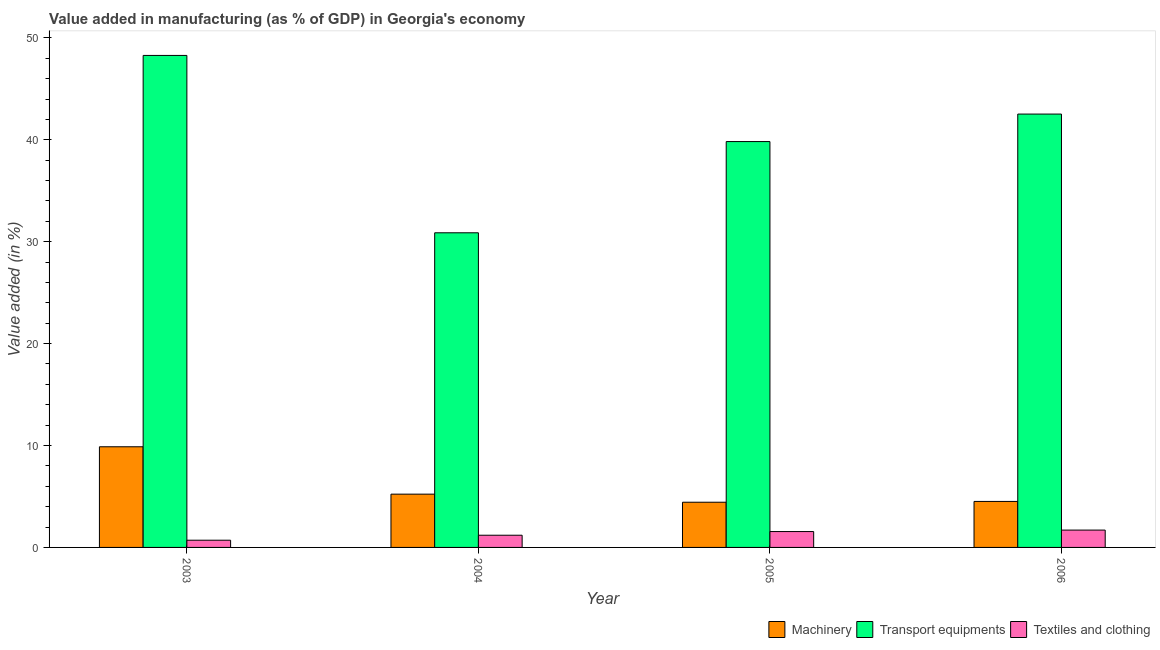How many different coloured bars are there?
Keep it short and to the point. 3. Are the number of bars on each tick of the X-axis equal?
Your answer should be very brief. Yes. In how many cases, is the number of bars for a given year not equal to the number of legend labels?
Your answer should be compact. 0. What is the value added in manufacturing machinery in 2005?
Your answer should be compact. 4.44. Across all years, what is the maximum value added in manufacturing transport equipments?
Give a very brief answer. 48.28. Across all years, what is the minimum value added in manufacturing textile and clothing?
Your answer should be very brief. 0.71. In which year was the value added in manufacturing textile and clothing minimum?
Provide a short and direct response. 2003. What is the total value added in manufacturing machinery in the graph?
Provide a succinct answer. 24.05. What is the difference between the value added in manufacturing machinery in 2005 and that in 2006?
Make the answer very short. -0.08. What is the difference between the value added in manufacturing transport equipments in 2005 and the value added in manufacturing machinery in 2004?
Keep it short and to the point. 8.95. What is the average value added in manufacturing transport equipments per year?
Your answer should be very brief. 40.37. In how many years, is the value added in manufacturing transport equipments greater than 4 %?
Provide a short and direct response. 4. What is the ratio of the value added in manufacturing machinery in 2004 to that in 2006?
Give a very brief answer. 1.16. What is the difference between the highest and the second highest value added in manufacturing transport equipments?
Make the answer very short. 5.75. What is the difference between the highest and the lowest value added in manufacturing transport equipments?
Your answer should be compact. 17.4. What does the 1st bar from the left in 2006 represents?
Provide a short and direct response. Machinery. What does the 2nd bar from the right in 2003 represents?
Keep it short and to the point. Transport equipments. Is it the case that in every year, the sum of the value added in manufacturing machinery and value added in manufacturing transport equipments is greater than the value added in manufacturing textile and clothing?
Offer a very short reply. Yes. How many bars are there?
Your response must be concise. 12. How many years are there in the graph?
Your answer should be compact. 4. What is the difference between two consecutive major ticks on the Y-axis?
Keep it short and to the point. 10. Does the graph contain any zero values?
Your answer should be very brief. No. How are the legend labels stacked?
Provide a succinct answer. Horizontal. What is the title of the graph?
Your answer should be very brief. Value added in manufacturing (as % of GDP) in Georgia's economy. What is the label or title of the Y-axis?
Provide a short and direct response. Value added (in %). What is the Value added (in %) in Machinery in 2003?
Give a very brief answer. 9.88. What is the Value added (in %) of Transport equipments in 2003?
Provide a short and direct response. 48.28. What is the Value added (in %) of Textiles and clothing in 2003?
Your answer should be compact. 0.71. What is the Value added (in %) of Machinery in 2004?
Give a very brief answer. 5.23. What is the Value added (in %) in Transport equipments in 2004?
Your response must be concise. 30.87. What is the Value added (in %) of Textiles and clothing in 2004?
Keep it short and to the point. 1.2. What is the Value added (in %) in Machinery in 2005?
Offer a terse response. 4.44. What is the Value added (in %) of Transport equipments in 2005?
Your answer should be compact. 39.82. What is the Value added (in %) of Textiles and clothing in 2005?
Offer a terse response. 1.56. What is the Value added (in %) in Machinery in 2006?
Your answer should be very brief. 4.51. What is the Value added (in %) of Transport equipments in 2006?
Provide a succinct answer. 42.52. What is the Value added (in %) of Textiles and clothing in 2006?
Your answer should be very brief. 1.7. Across all years, what is the maximum Value added (in %) in Machinery?
Offer a terse response. 9.88. Across all years, what is the maximum Value added (in %) of Transport equipments?
Ensure brevity in your answer.  48.28. Across all years, what is the maximum Value added (in %) in Textiles and clothing?
Your answer should be compact. 1.7. Across all years, what is the minimum Value added (in %) in Machinery?
Keep it short and to the point. 4.44. Across all years, what is the minimum Value added (in %) in Transport equipments?
Keep it short and to the point. 30.87. Across all years, what is the minimum Value added (in %) in Textiles and clothing?
Your answer should be compact. 0.71. What is the total Value added (in %) in Machinery in the graph?
Your answer should be very brief. 24.05. What is the total Value added (in %) of Transport equipments in the graph?
Provide a short and direct response. 161.5. What is the total Value added (in %) of Textiles and clothing in the graph?
Make the answer very short. 5.16. What is the difference between the Value added (in %) of Machinery in 2003 and that in 2004?
Your answer should be compact. 4.65. What is the difference between the Value added (in %) in Transport equipments in 2003 and that in 2004?
Your answer should be very brief. 17.4. What is the difference between the Value added (in %) of Textiles and clothing in 2003 and that in 2004?
Give a very brief answer. -0.49. What is the difference between the Value added (in %) of Machinery in 2003 and that in 2005?
Provide a short and direct response. 5.44. What is the difference between the Value added (in %) in Transport equipments in 2003 and that in 2005?
Your answer should be very brief. 8.45. What is the difference between the Value added (in %) of Textiles and clothing in 2003 and that in 2005?
Your answer should be compact. -0.85. What is the difference between the Value added (in %) of Machinery in 2003 and that in 2006?
Your answer should be compact. 5.36. What is the difference between the Value added (in %) in Transport equipments in 2003 and that in 2006?
Give a very brief answer. 5.75. What is the difference between the Value added (in %) of Textiles and clothing in 2003 and that in 2006?
Your response must be concise. -0.99. What is the difference between the Value added (in %) of Machinery in 2004 and that in 2005?
Keep it short and to the point. 0.79. What is the difference between the Value added (in %) of Transport equipments in 2004 and that in 2005?
Provide a succinct answer. -8.95. What is the difference between the Value added (in %) in Textiles and clothing in 2004 and that in 2005?
Your response must be concise. -0.36. What is the difference between the Value added (in %) in Machinery in 2004 and that in 2006?
Provide a succinct answer. 0.71. What is the difference between the Value added (in %) in Transport equipments in 2004 and that in 2006?
Offer a very short reply. -11.65. What is the difference between the Value added (in %) in Textiles and clothing in 2004 and that in 2006?
Provide a succinct answer. -0.51. What is the difference between the Value added (in %) of Machinery in 2005 and that in 2006?
Provide a short and direct response. -0.08. What is the difference between the Value added (in %) in Transport equipments in 2005 and that in 2006?
Offer a terse response. -2.7. What is the difference between the Value added (in %) of Textiles and clothing in 2005 and that in 2006?
Your answer should be compact. -0.15. What is the difference between the Value added (in %) of Machinery in 2003 and the Value added (in %) of Transport equipments in 2004?
Your answer should be compact. -21. What is the difference between the Value added (in %) in Machinery in 2003 and the Value added (in %) in Textiles and clothing in 2004?
Your answer should be compact. 8.68. What is the difference between the Value added (in %) of Transport equipments in 2003 and the Value added (in %) of Textiles and clothing in 2004?
Your answer should be very brief. 47.08. What is the difference between the Value added (in %) of Machinery in 2003 and the Value added (in %) of Transport equipments in 2005?
Offer a terse response. -29.95. What is the difference between the Value added (in %) of Machinery in 2003 and the Value added (in %) of Textiles and clothing in 2005?
Provide a succinct answer. 8.32. What is the difference between the Value added (in %) in Transport equipments in 2003 and the Value added (in %) in Textiles and clothing in 2005?
Ensure brevity in your answer.  46.72. What is the difference between the Value added (in %) of Machinery in 2003 and the Value added (in %) of Transport equipments in 2006?
Ensure brevity in your answer.  -32.65. What is the difference between the Value added (in %) of Machinery in 2003 and the Value added (in %) of Textiles and clothing in 2006?
Provide a short and direct response. 8.17. What is the difference between the Value added (in %) in Transport equipments in 2003 and the Value added (in %) in Textiles and clothing in 2006?
Provide a succinct answer. 46.57. What is the difference between the Value added (in %) in Machinery in 2004 and the Value added (in %) in Transport equipments in 2005?
Provide a short and direct response. -34.6. What is the difference between the Value added (in %) of Machinery in 2004 and the Value added (in %) of Textiles and clothing in 2005?
Offer a very short reply. 3.67. What is the difference between the Value added (in %) of Transport equipments in 2004 and the Value added (in %) of Textiles and clothing in 2005?
Your answer should be compact. 29.32. What is the difference between the Value added (in %) in Machinery in 2004 and the Value added (in %) in Transport equipments in 2006?
Ensure brevity in your answer.  -37.29. What is the difference between the Value added (in %) in Machinery in 2004 and the Value added (in %) in Textiles and clothing in 2006?
Offer a very short reply. 3.53. What is the difference between the Value added (in %) in Transport equipments in 2004 and the Value added (in %) in Textiles and clothing in 2006?
Give a very brief answer. 29.17. What is the difference between the Value added (in %) in Machinery in 2005 and the Value added (in %) in Transport equipments in 2006?
Offer a terse response. -38.09. What is the difference between the Value added (in %) of Machinery in 2005 and the Value added (in %) of Textiles and clothing in 2006?
Make the answer very short. 2.73. What is the difference between the Value added (in %) of Transport equipments in 2005 and the Value added (in %) of Textiles and clothing in 2006?
Ensure brevity in your answer.  38.12. What is the average Value added (in %) of Machinery per year?
Your answer should be compact. 6.01. What is the average Value added (in %) of Transport equipments per year?
Keep it short and to the point. 40.37. What is the average Value added (in %) in Textiles and clothing per year?
Give a very brief answer. 1.29. In the year 2003, what is the difference between the Value added (in %) of Machinery and Value added (in %) of Transport equipments?
Your response must be concise. -38.4. In the year 2003, what is the difference between the Value added (in %) in Machinery and Value added (in %) in Textiles and clothing?
Your answer should be compact. 9.17. In the year 2003, what is the difference between the Value added (in %) in Transport equipments and Value added (in %) in Textiles and clothing?
Your response must be concise. 47.57. In the year 2004, what is the difference between the Value added (in %) of Machinery and Value added (in %) of Transport equipments?
Provide a short and direct response. -25.65. In the year 2004, what is the difference between the Value added (in %) of Machinery and Value added (in %) of Textiles and clothing?
Offer a very short reply. 4.03. In the year 2004, what is the difference between the Value added (in %) of Transport equipments and Value added (in %) of Textiles and clothing?
Make the answer very short. 29.68. In the year 2005, what is the difference between the Value added (in %) of Machinery and Value added (in %) of Transport equipments?
Your answer should be very brief. -35.39. In the year 2005, what is the difference between the Value added (in %) in Machinery and Value added (in %) in Textiles and clothing?
Your response must be concise. 2.88. In the year 2005, what is the difference between the Value added (in %) of Transport equipments and Value added (in %) of Textiles and clothing?
Your answer should be compact. 38.27. In the year 2006, what is the difference between the Value added (in %) of Machinery and Value added (in %) of Transport equipments?
Your answer should be compact. -38.01. In the year 2006, what is the difference between the Value added (in %) in Machinery and Value added (in %) in Textiles and clothing?
Provide a short and direct response. 2.81. In the year 2006, what is the difference between the Value added (in %) in Transport equipments and Value added (in %) in Textiles and clothing?
Your response must be concise. 40.82. What is the ratio of the Value added (in %) in Machinery in 2003 to that in 2004?
Make the answer very short. 1.89. What is the ratio of the Value added (in %) of Transport equipments in 2003 to that in 2004?
Offer a terse response. 1.56. What is the ratio of the Value added (in %) of Textiles and clothing in 2003 to that in 2004?
Your answer should be compact. 0.59. What is the ratio of the Value added (in %) of Machinery in 2003 to that in 2005?
Provide a short and direct response. 2.23. What is the ratio of the Value added (in %) in Transport equipments in 2003 to that in 2005?
Your answer should be very brief. 1.21. What is the ratio of the Value added (in %) of Textiles and clothing in 2003 to that in 2005?
Ensure brevity in your answer.  0.45. What is the ratio of the Value added (in %) of Machinery in 2003 to that in 2006?
Ensure brevity in your answer.  2.19. What is the ratio of the Value added (in %) in Transport equipments in 2003 to that in 2006?
Offer a very short reply. 1.14. What is the ratio of the Value added (in %) in Textiles and clothing in 2003 to that in 2006?
Your response must be concise. 0.42. What is the ratio of the Value added (in %) of Machinery in 2004 to that in 2005?
Your answer should be compact. 1.18. What is the ratio of the Value added (in %) of Transport equipments in 2004 to that in 2005?
Ensure brevity in your answer.  0.78. What is the ratio of the Value added (in %) of Textiles and clothing in 2004 to that in 2005?
Provide a succinct answer. 0.77. What is the ratio of the Value added (in %) in Machinery in 2004 to that in 2006?
Provide a short and direct response. 1.16. What is the ratio of the Value added (in %) of Transport equipments in 2004 to that in 2006?
Make the answer very short. 0.73. What is the ratio of the Value added (in %) in Textiles and clothing in 2004 to that in 2006?
Your response must be concise. 0.7. What is the ratio of the Value added (in %) in Machinery in 2005 to that in 2006?
Offer a very short reply. 0.98. What is the ratio of the Value added (in %) in Transport equipments in 2005 to that in 2006?
Provide a short and direct response. 0.94. What is the ratio of the Value added (in %) in Textiles and clothing in 2005 to that in 2006?
Provide a succinct answer. 0.91. What is the difference between the highest and the second highest Value added (in %) of Machinery?
Your answer should be compact. 4.65. What is the difference between the highest and the second highest Value added (in %) in Transport equipments?
Make the answer very short. 5.75. What is the difference between the highest and the second highest Value added (in %) in Textiles and clothing?
Make the answer very short. 0.15. What is the difference between the highest and the lowest Value added (in %) in Machinery?
Ensure brevity in your answer.  5.44. What is the difference between the highest and the lowest Value added (in %) in Transport equipments?
Your answer should be very brief. 17.4. 